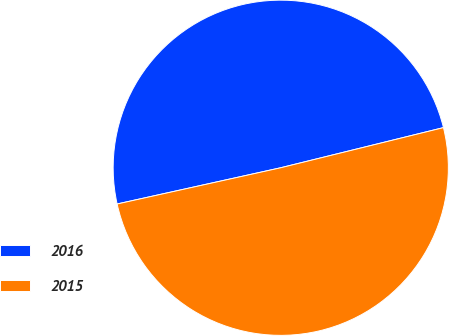<chart> <loc_0><loc_0><loc_500><loc_500><pie_chart><fcel>2016<fcel>2015<nl><fcel>49.62%<fcel>50.38%<nl></chart> 